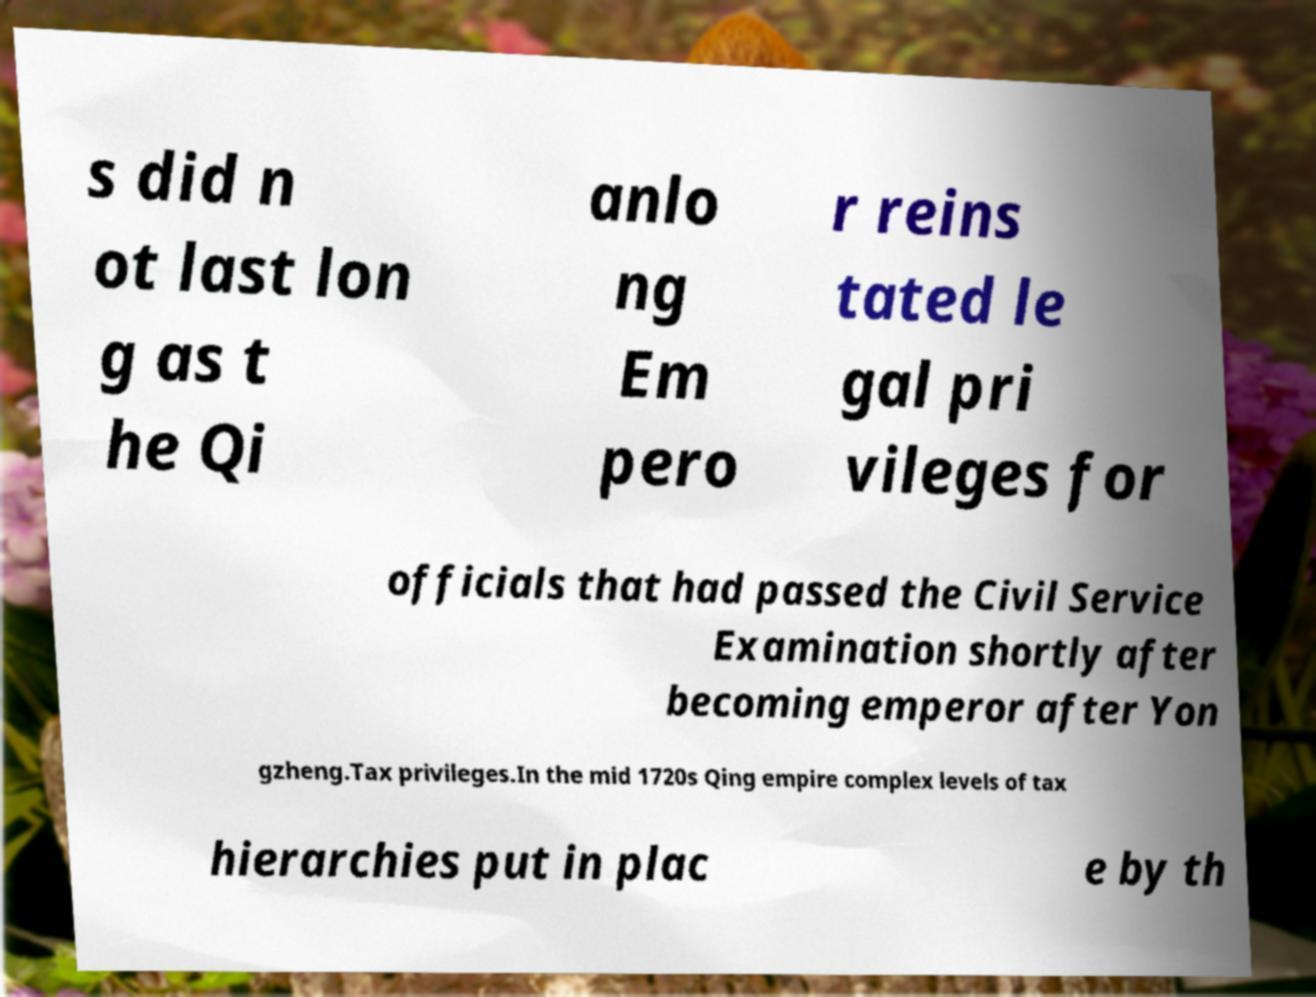For documentation purposes, I need the text within this image transcribed. Could you provide that? s did n ot last lon g as t he Qi anlo ng Em pero r reins tated le gal pri vileges for officials that had passed the Civil Service Examination shortly after becoming emperor after Yon gzheng.Tax privileges.In the mid 1720s Qing empire complex levels of tax hierarchies put in plac e by th 